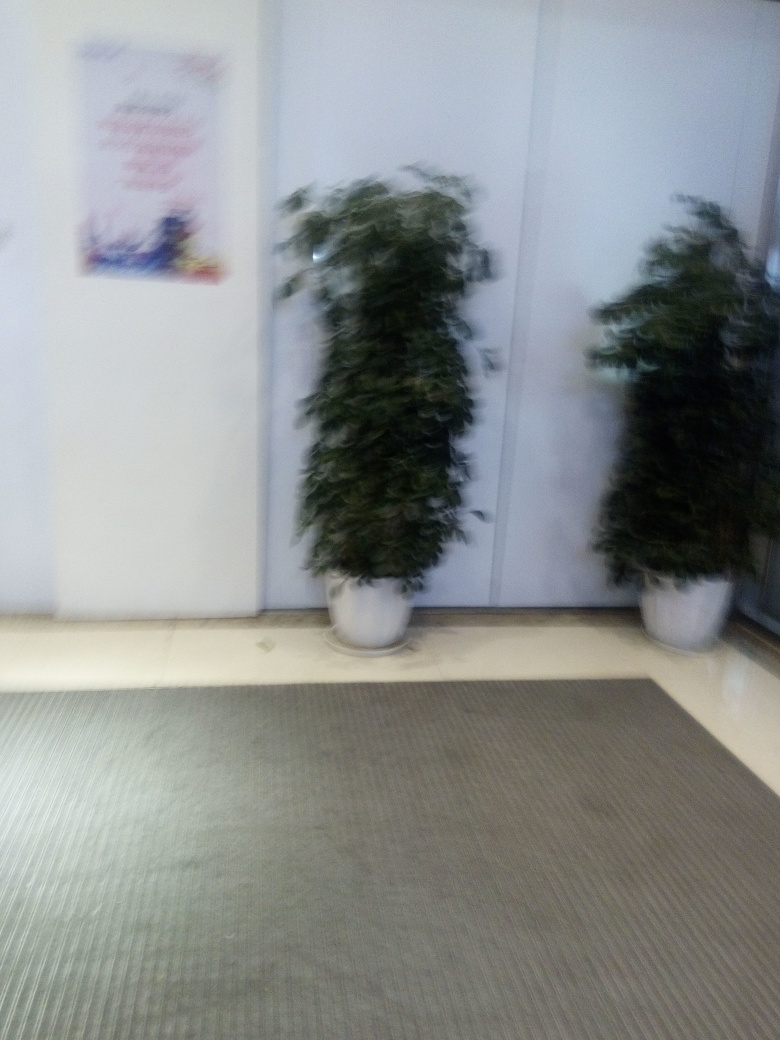Is the overall quality of this photo low?
A. No
B. Yes
Answer with the option's letter from the given choices directly.
 B. 